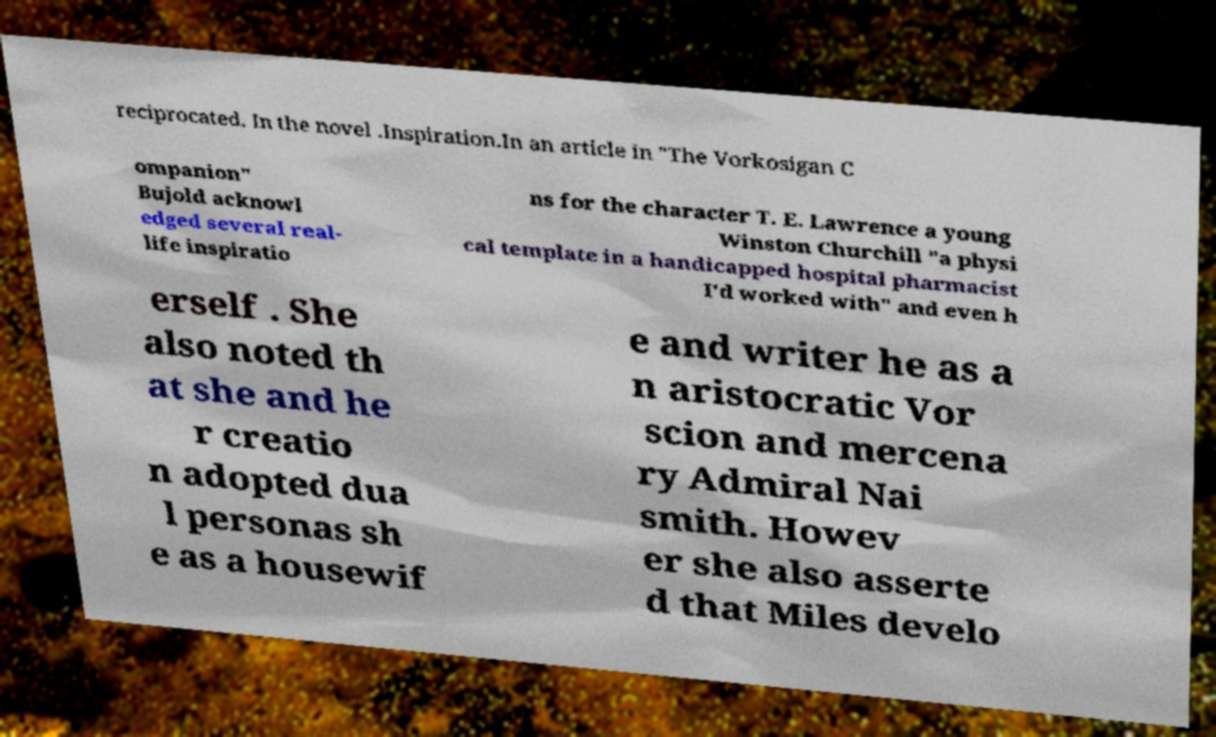What messages or text are displayed in this image? I need them in a readable, typed format. reciprocated. In the novel .Inspiration.In an article in "The Vorkosigan C ompanion" Bujold acknowl edged several real- life inspiratio ns for the character T. E. Lawrence a young Winston Churchill "a physi cal template in a handicapped hospital pharmacist I'd worked with" and even h erself . She also noted th at she and he r creatio n adopted dua l personas sh e as a housewif e and writer he as a n aristocratic Vor scion and mercena ry Admiral Nai smith. Howev er she also asserte d that Miles develo 